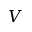<formula> <loc_0><loc_0><loc_500><loc_500>V</formula> 